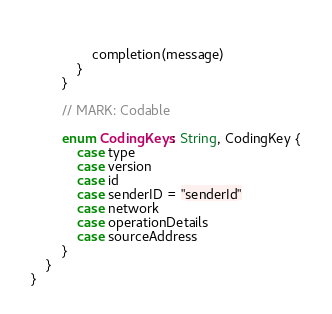<code> <loc_0><loc_0><loc_500><loc_500><_Swift_>                
                completion(message)
            }
        }
        
        // MARK: Codable
        
        enum CodingKeys: String, CodingKey {
            case type
            case version
            case id
            case senderID = "senderId"
            case network
            case operationDetails
            case sourceAddress
        }
    }
}
</code> 